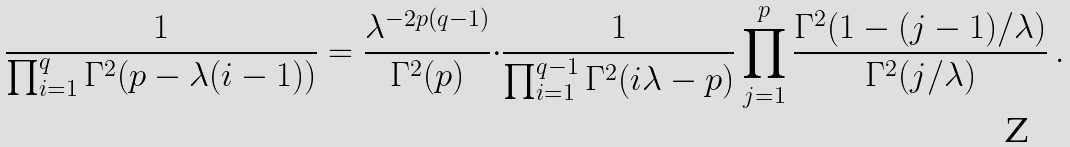Convert formula to latex. <formula><loc_0><loc_0><loc_500><loc_500>\frac { 1 } { \prod _ { i = 1 } ^ { q } \Gamma ^ { 2 } ( p - \lambda ( i - 1 ) ) } = \frac { \lambda ^ { - 2 p ( q - 1 ) } } { \Gamma ^ { 2 } ( p ) } { \cdot } \frac { 1 } { \prod _ { i = 1 } ^ { q - 1 } \Gamma ^ { 2 } ( i \lambda - p ) } \prod _ { j = 1 } ^ { p } \frac { \Gamma ^ { 2 } ( 1 - ( j - 1 ) / \lambda ) } { \Gamma ^ { 2 } ( j / \lambda ) } \, .</formula> 